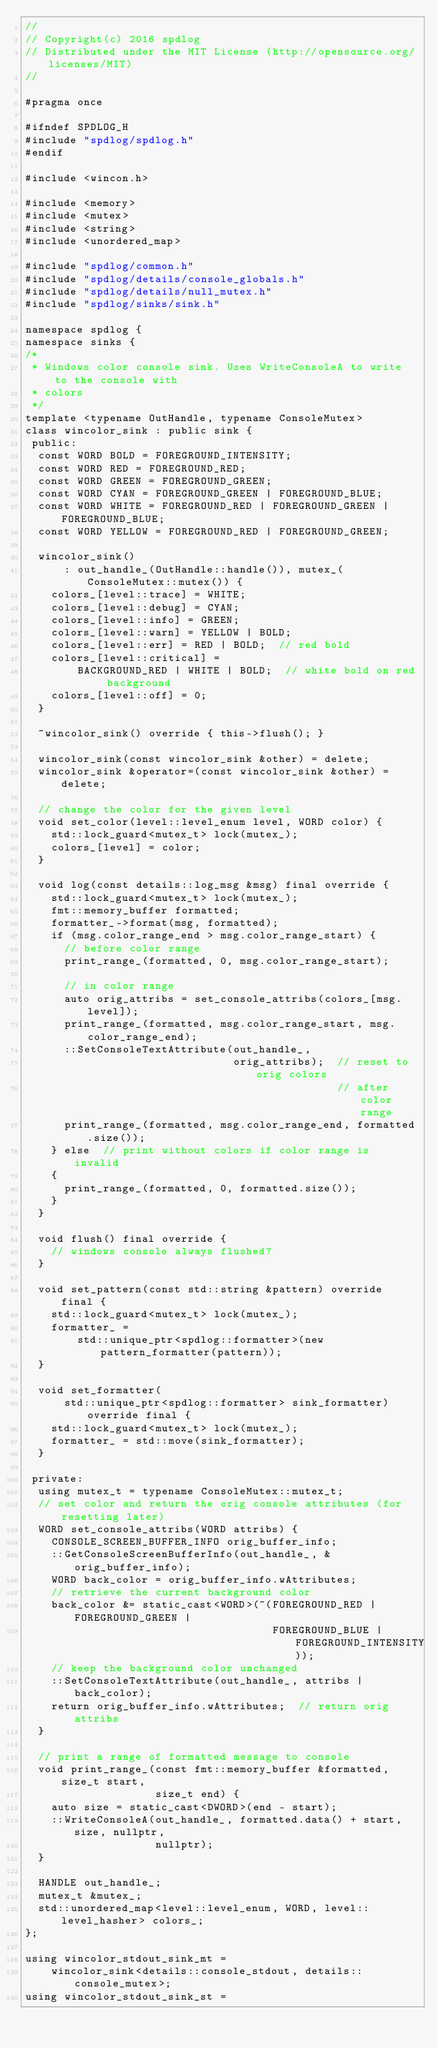Convert code to text. <code><loc_0><loc_0><loc_500><loc_500><_C_>//
// Copyright(c) 2016 spdlog
// Distributed under the MIT License (http://opensource.org/licenses/MIT)
//

#pragma once

#ifndef SPDLOG_H
#include "spdlog/spdlog.h"
#endif

#include <wincon.h>

#include <memory>
#include <mutex>
#include <string>
#include <unordered_map>

#include "spdlog/common.h"
#include "spdlog/details/console_globals.h"
#include "spdlog/details/null_mutex.h"
#include "spdlog/sinks/sink.h"

namespace spdlog {
namespace sinks {
/*
 * Windows color console sink. Uses WriteConsoleA to write to the console with
 * colors
 */
template <typename OutHandle, typename ConsoleMutex>
class wincolor_sink : public sink {
 public:
  const WORD BOLD = FOREGROUND_INTENSITY;
  const WORD RED = FOREGROUND_RED;
  const WORD GREEN = FOREGROUND_GREEN;
  const WORD CYAN = FOREGROUND_GREEN | FOREGROUND_BLUE;
  const WORD WHITE = FOREGROUND_RED | FOREGROUND_GREEN | FOREGROUND_BLUE;
  const WORD YELLOW = FOREGROUND_RED | FOREGROUND_GREEN;

  wincolor_sink()
      : out_handle_(OutHandle::handle()), mutex_(ConsoleMutex::mutex()) {
    colors_[level::trace] = WHITE;
    colors_[level::debug] = CYAN;
    colors_[level::info] = GREEN;
    colors_[level::warn] = YELLOW | BOLD;
    colors_[level::err] = RED | BOLD;  // red bold
    colors_[level::critical] =
        BACKGROUND_RED | WHITE | BOLD;  // white bold on red background
    colors_[level::off] = 0;
  }

  ~wincolor_sink() override { this->flush(); }

  wincolor_sink(const wincolor_sink &other) = delete;
  wincolor_sink &operator=(const wincolor_sink &other) = delete;

  // change the color for the given level
  void set_color(level::level_enum level, WORD color) {
    std::lock_guard<mutex_t> lock(mutex_);
    colors_[level] = color;
  }

  void log(const details::log_msg &msg) final override {
    std::lock_guard<mutex_t> lock(mutex_);
    fmt::memory_buffer formatted;
    formatter_->format(msg, formatted);
    if (msg.color_range_end > msg.color_range_start) {
      // before color range
      print_range_(formatted, 0, msg.color_range_start);

      // in color range
      auto orig_attribs = set_console_attribs(colors_[msg.level]);
      print_range_(formatted, msg.color_range_start, msg.color_range_end);
      ::SetConsoleTextAttribute(out_handle_,
                                orig_attribs);  // reset to orig colors
                                                // after color range
      print_range_(formatted, msg.color_range_end, formatted.size());
    } else  // print without colors if color range is invalid
    {
      print_range_(formatted, 0, formatted.size());
    }
  }

  void flush() final override {
    // windows console always flushed?
  }

  void set_pattern(const std::string &pattern) override final {
    std::lock_guard<mutex_t> lock(mutex_);
    formatter_ =
        std::unique_ptr<spdlog::formatter>(new pattern_formatter(pattern));
  }

  void set_formatter(
      std::unique_ptr<spdlog::formatter> sink_formatter) override final {
    std::lock_guard<mutex_t> lock(mutex_);
    formatter_ = std::move(sink_formatter);
  }

 private:
  using mutex_t = typename ConsoleMutex::mutex_t;
  // set color and return the orig console attributes (for resetting later)
  WORD set_console_attribs(WORD attribs) {
    CONSOLE_SCREEN_BUFFER_INFO orig_buffer_info;
    ::GetConsoleScreenBufferInfo(out_handle_, &orig_buffer_info);
    WORD back_color = orig_buffer_info.wAttributes;
    // retrieve the current background color
    back_color &= static_cast<WORD>(~(FOREGROUND_RED | FOREGROUND_GREEN |
                                      FOREGROUND_BLUE | FOREGROUND_INTENSITY));
    // keep the background color unchanged
    ::SetConsoleTextAttribute(out_handle_, attribs | back_color);
    return orig_buffer_info.wAttributes;  // return orig attribs
  }

  // print a range of formatted message to console
  void print_range_(const fmt::memory_buffer &formatted, size_t start,
                    size_t end) {
    auto size = static_cast<DWORD>(end - start);
    ::WriteConsoleA(out_handle_, formatted.data() + start, size, nullptr,
                    nullptr);
  }

  HANDLE out_handle_;
  mutex_t &mutex_;
  std::unordered_map<level::level_enum, WORD, level::level_hasher> colors_;
};

using wincolor_stdout_sink_mt =
    wincolor_sink<details::console_stdout, details::console_mutex>;
using wincolor_stdout_sink_st =</code> 